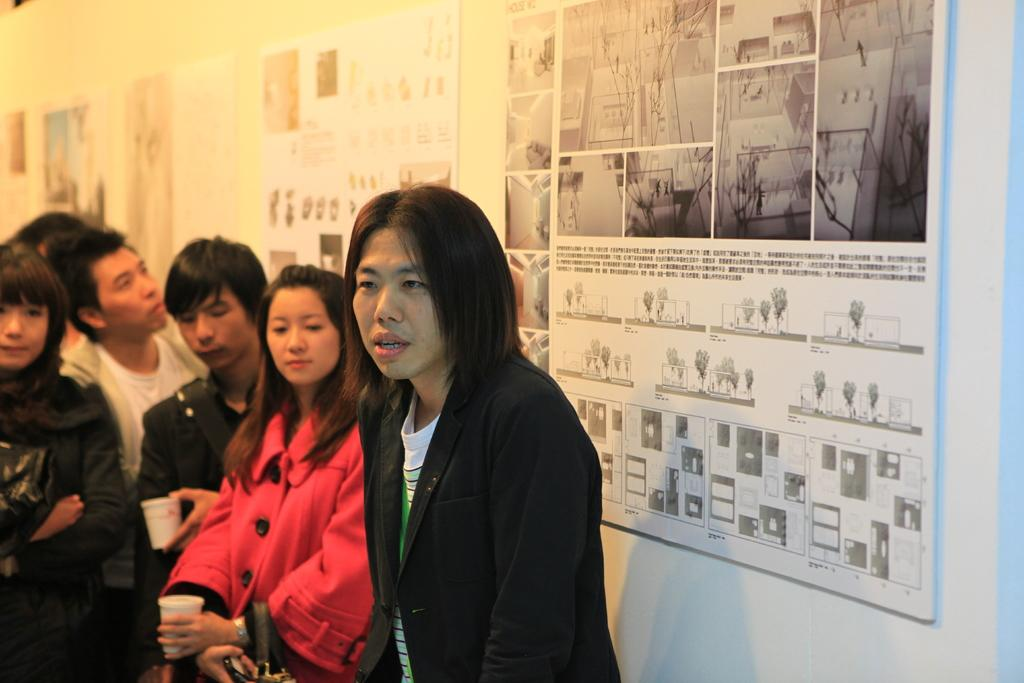What type of view is shown in the image? The image is an inside view. What are the people in the image wearing? The people are wearing jackets in the image. What are the people doing in the image? The people are standing in the image. What can be seen attached to the wall in the image? There are posts attached to the wall in the image. What type of stretch can be seen on the wall in the image? There is no stretch visible on the wall in the image. 